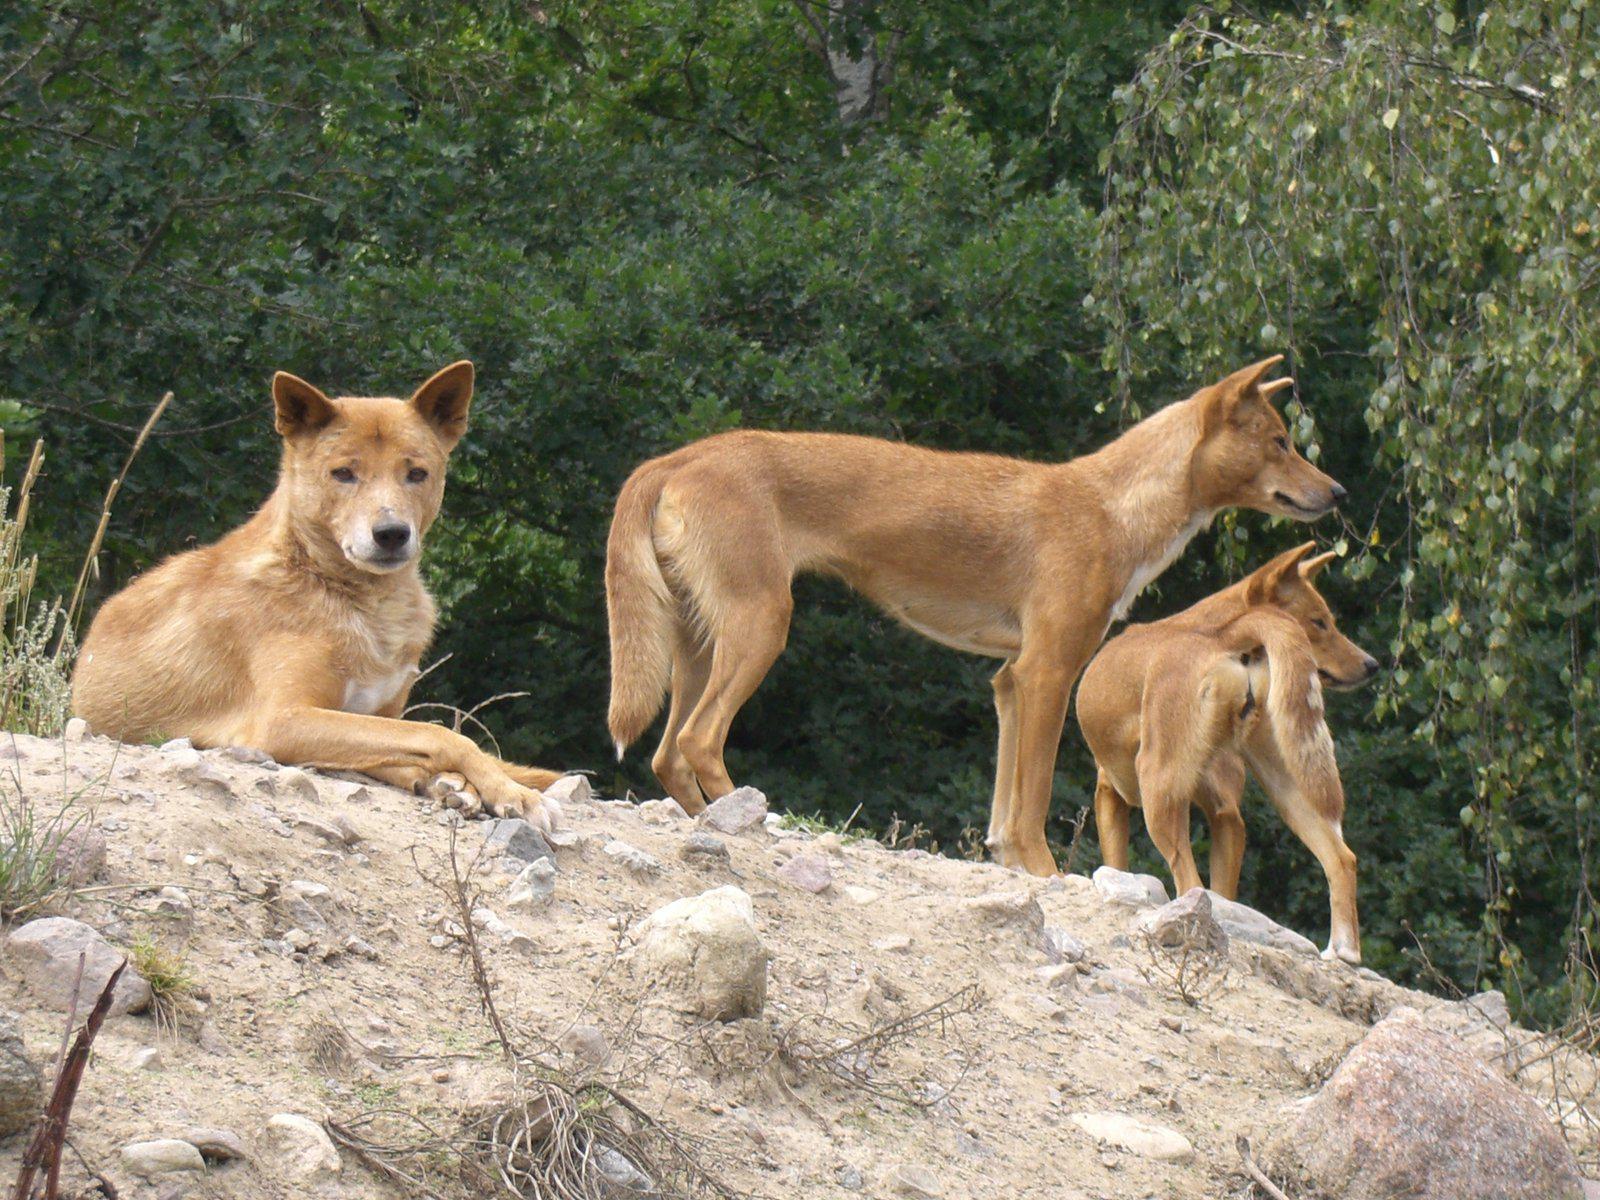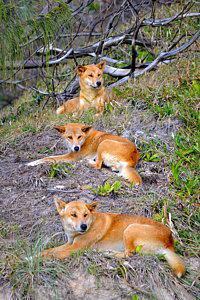The first image is the image on the left, the second image is the image on the right. For the images displayed, is the sentence "There are two animals in total." factually correct? Answer yes or no. No. The first image is the image on the left, the second image is the image on the right. For the images shown, is this caption "The left image contains at least two dingos." true? Answer yes or no. Yes. 